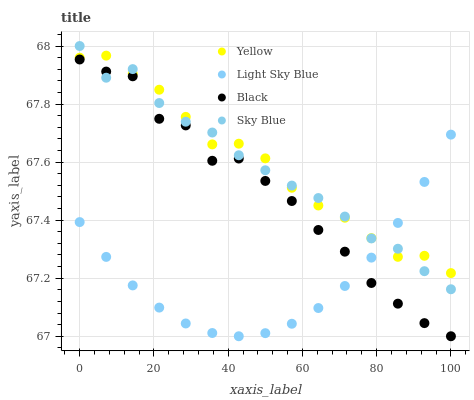Does Light Sky Blue have the minimum area under the curve?
Answer yes or no. Yes. Does Yellow have the maximum area under the curve?
Answer yes or no. Yes. Does Black have the minimum area under the curve?
Answer yes or no. No. Does Black have the maximum area under the curve?
Answer yes or no. No. Is Light Sky Blue the smoothest?
Answer yes or no. Yes. Is Black the roughest?
Answer yes or no. Yes. Is Black the smoothest?
Answer yes or no. No. Is Light Sky Blue the roughest?
Answer yes or no. No. Does Black have the lowest value?
Answer yes or no. Yes. Does Light Sky Blue have the lowest value?
Answer yes or no. No. Does Sky Blue have the highest value?
Answer yes or no. Yes. Does Black have the highest value?
Answer yes or no. No. Is Black less than Yellow?
Answer yes or no. Yes. Is Yellow greater than Black?
Answer yes or no. Yes. Does Yellow intersect Light Sky Blue?
Answer yes or no. Yes. Is Yellow less than Light Sky Blue?
Answer yes or no. No. Is Yellow greater than Light Sky Blue?
Answer yes or no. No. Does Black intersect Yellow?
Answer yes or no. No. 